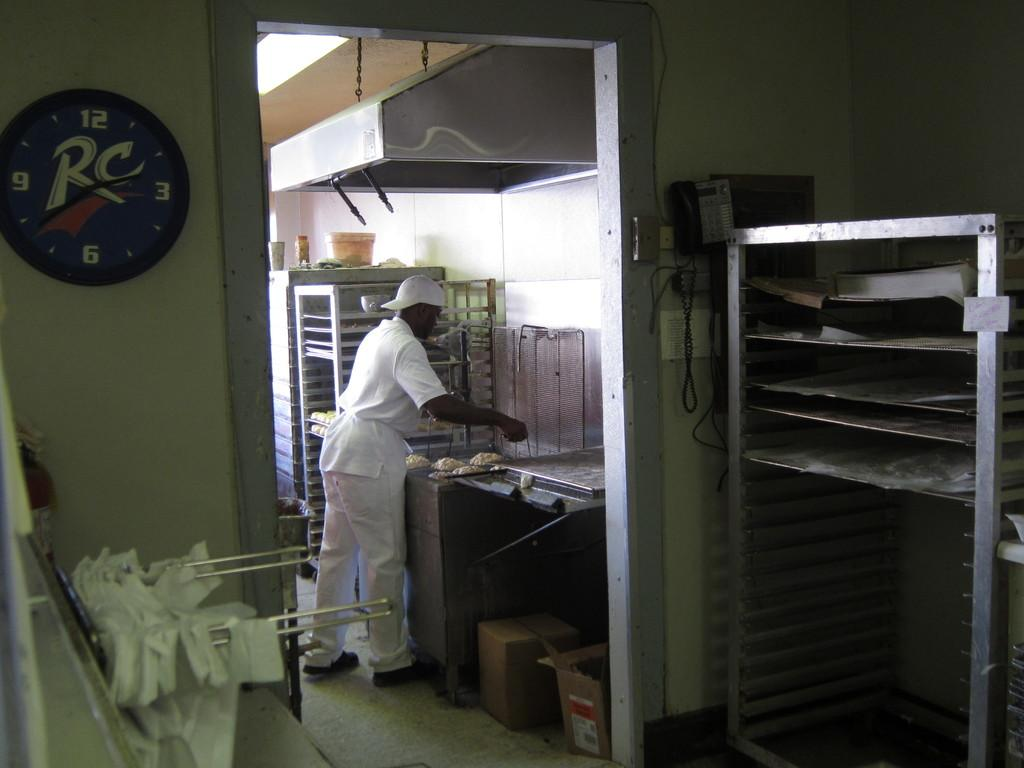<image>
Present a compact description of the photo's key features. A man preparing some food in a kitchen with an RC clock. 